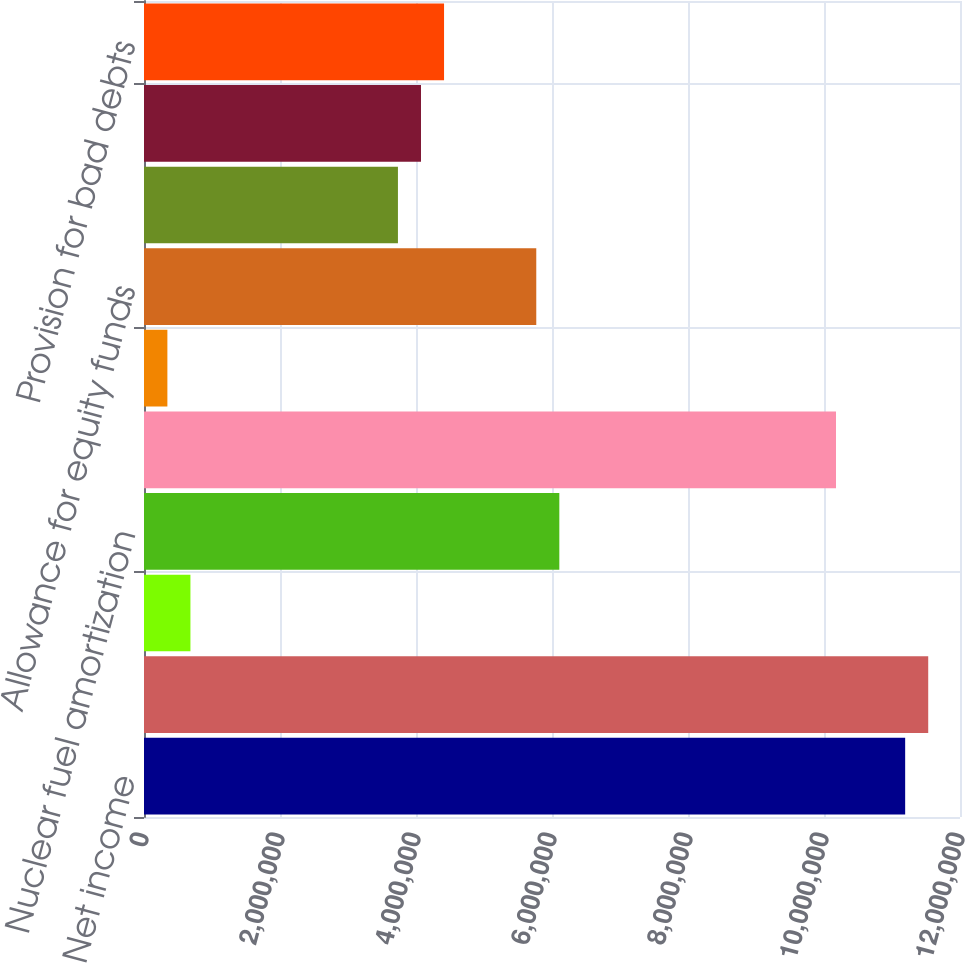Convert chart to OTSL. <chart><loc_0><loc_0><loc_500><loc_500><bar_chart><fcel>Net income<fcel>Depreciation and amortization<fcel>Conservation and demand side<fcel>Nuclear fuel amortization<fcel>Deferred income taxes<fcel>Amortization of investment tax<fcel>Allowance for equity funds<fcel>Equity earnings of<fcel>Dividends from unconsolidated<fcel>Provision for bad debts<nl><fcel>1.11936e+07<fcel>1.15327e+07<fcel>682878<fcel>6.10777e+06<fcel>1.01764e+07<fcel>343822<fcel>5.76872e+06<fcel>3.73438e+06<fcel>4.07344e+06<fcel>4.41249e+06<nl></chart> 